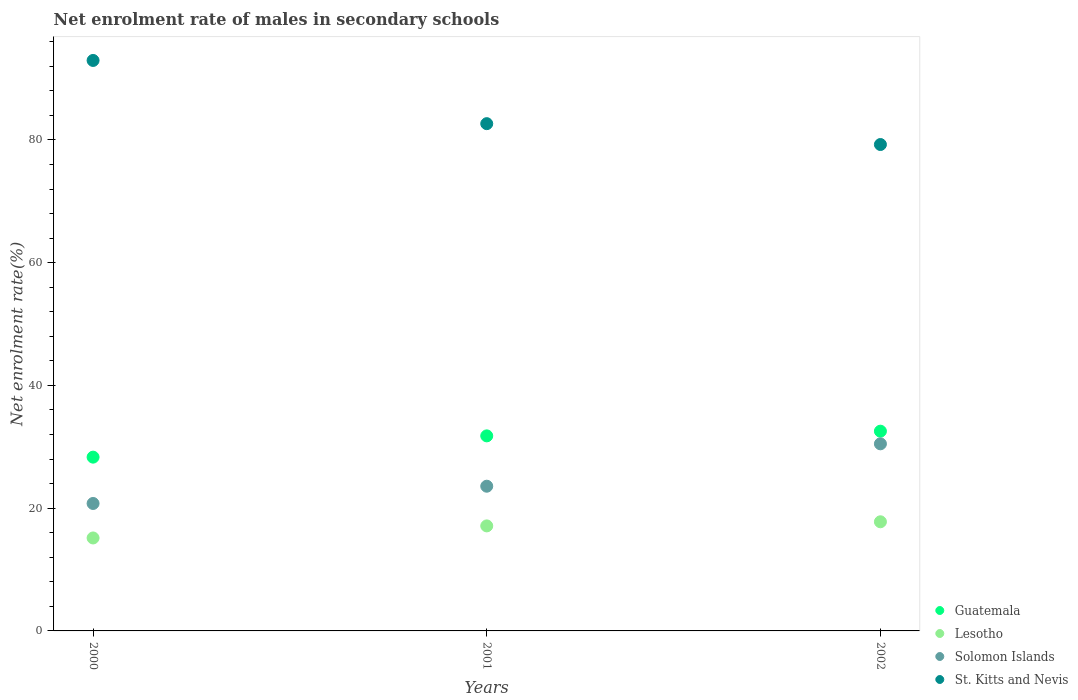How many different coloured dotlines are there?
Give a very brief answer. 4. What is the net enrolment rate of males in secondary schools in St. Kitts and Nevis in 2000?
Offer a very short reply. 92.95. Across all years, what is the maximum net enrolment rate of males in secondary schools in Guatemala?
Your answer should be very brief. 32.54. Across all years, what is the minimum net enrolment rate of males in secondary schools in Lesotho?
Offer a terse response. 15.15. What is the total net enrolment rate of males in secondary schools in Guatemala in the graph?
Your answer should be compact. 92.64. What is the difference between the net enrolment rate of males in secondary schools in Lesotho in 2000 and that in 2002?
Offer a terse response. -2.64. What is the difference between the net enrolment rate of males in secondary schools in Solomon Islands in 2001 and the net enrolment rate of males in secondary schools in Lesotho in 2000?
Offer a very short reply. 8.43. What is the average net enrolment rate of males in secondary schools in Guatemala per year?
Make the answer very short. 30.88. In the year 2002, what is the difference between the net enrolment rate of males in secondary schools in Solomon Islands and net enrolment rate of males in secondary schools in Guatemala?
Keep it short and to the point. -2.06. In how many years, is the net enrolment rate of males in secondary schools in Solomon Islands greater than 84 %?
Provide a short and direct response. 0. What is the ratio of the net enrolment rate of males in secondary schools in St. Kitts and Nevis in 2000 to that in 2002?
Keep it short and to the point. 1.17. Is the net enrolment rate of males in secondary schools in Solomon Islands in 2001 less than that in 2002?
Your response must be concise. Yes. What is the difference between the highest and the second highest net enrolment rate of males in secondary schools in Guatemala?
Your response must be concise. 0.76. What is the difference between the highest and the lowest net enrolment rate of males in secondary schools in St. Kitts and Nevis?
Provide a succinct answer. 13.7. Is it the case that in every year, the sum of the net enrolment rate of males in secondary schools in St. Kitts and Nevis and net enrolment rate of males in secondary schools in Lesotho  is greater than the net enrolment rate of males in secondary schools in Guatemala?
Offer a very short reply. Yes. Does the net enrolment rate of males in secondary schools in Lesotho monotonically increase over the years?
Your response must be concise. Yes. Is the net enrolment rate of males in secondary schools in Guatemala strictly less than the net enrolment rate of males in secondary schools in Lesotho over the years?
Your response must be concise. No. How many dotlines are there?
Your answer should be compact. 4. Are the values on the major ticks of Y-axis written in scientific E-notation?
Ensure brevity in your answer.  No. Does the graph contain any zero values?
Offer a terse response. No. Does the graph contain grids?
Provide a short and direct response. No. Where does the legend appear in the graph?
Provide a succinct answer. Bottom right. What is the title of the graph?
Keep it short and to the point. Net enrolment rate of males in secondary schools. What is the label or title of the Y-axis?
Offer a terse response. Net enrolment rate(%). What is the Net enrolment rate(%) of Guatemala in 2000?
Your answer should be very brief. 28.31. What is the Net enrolment rate(%) in Lesotho in 2000?
Keep it short and to the point. 15.15. What is the Net enrolment rate(%) of Solomon Islands in 2000?
Your response must be concise. 20.77. What is the Net enrolment rate(%) in St. Kitts and Nevis in 2000?
Provide a succinct answer. 92.95. What is the Net enrolment rate(%) of Guatemala in 2001?
Offer a very short reply. 31.78. What is the Net enrolment rate(%) in Lesotho in 2001?
Offer a very short reply. 17.11. What is the Net enrolment rate(%) of Solomon Islands in 2001?
Keep it short and to the point. 23.58. What is the Net enrolment rate(%) of St. Kitts and Nevis in 2001?
Make the answer very short. 82.65. What is the Net enrolment rate(%) of Guatemala in 2002?
Provide a succinct answer. 32.54. What is the Net enrolment rate(%) of Lesotho in 2002?
Your answer should be very brief. 17.78. What is the Net enrolment rate(%) of Solomon Islands in 2002?
Your answer should be compact. 30.48. What is the Net enrolment rate(%) in St. Kitts and Nevis in 2002?
Offer a terse response. 79.25. Across all years, what is the maximum Net enrolment rate(%) in Guatemala?
Provide a short and direct response. 32.54. Across all years, what is the maximum Net enrolment rate(%) in Lesotho?
Offer a terse response. 17.78. Across all years, what is the maximum Net enrolment rate(%) in Solomon Islands?
Offer a very short reply. 30.48. Across all years, what is the maximum Net enrolment rate(%) of St. Kitts and Nevis?
Your answer should be compact. 92.95. Across all years, what is the minimum Net enrolment rate(%) in Guatemala?
Ensure brevity in your answer.  28.31. Across all years, what is the minimum Net enrolment rate(%) in Lesotho?
Provide a succinct answer. 15.15. Across all years, what is the minimum Net enrolment rate(%) in Solomon Islands?
Give a very brief answer. 20.77. Across all years, what is the minimum Net enrolment rate(%) in St. Kitts and Nevis?
Keep it short and to the point. 79.25. What is the total Net enrolment rate(%) of Guatemala in the graph?
Provide a short and direct response. 92.64. What is the total Net enrolment rate(%) of Lesotho in the graph?
Make the answer very short. 50.04. What is the total Net enrolment rate(%) of Solomon Islands in the graph?
Make the answer very short. 74.83. What is the total Net enrolment rate(%) of St. Kitts and Nevis in the graph?
Your answer should be compact. 254.85. What is the difference between the Net enrolment rate(%) of Guatemala in 2000 and that in 2001?
Give a very brief answer. -3.47. What is the difference between the Net enrolment rate(%) in Lesotho in 2000 and that in 2001?
Provide a short and direct response. -1.97. What is the difference between the Net enrolment rate(%) of Solomon Islands in 2000 and that in 2001?
Offer a terse response. -2.81. What is the difference between the Net enrolment rate(%) of St. Kitts and Nevis in 2000 and that in 2001?
Offer a terse response. 10.3. What is the difference between the Net enrolment rate(%) of Guatemala in 2000 and that in 2002?
Provide a short and direct response. -4.23. What is the difference between the Net enrolment rate(%) of Lesotho in 2000 and that in 2002?
Give a very brief answer. -2.64. What is the difference between the Net enrolment rate(%) in Solomon Islands in 2000 and that in 2002?
Your answer should be compact. -9.72. What is the difference between the Net enrolment rate(%) in St. Kitts and Nevis in 2000 and that in 2002?
Provide a short and direct response. 13.7. What is the difference between the Net enrolment rate(%) of Guatemala in 2001 and that in 2002?
Your answer should be very brief. -0.76. What is the difference between the Net enrolment rate(%) in Lesotho in 2001 and that in 2002?
Provide a succinct answer. -0.67. What is the difference between the Net enrolment rate(%) of Solomon Islands in 2001 and that in 2002?
Provide a succinct answer. -6.91. What is the difference between the Net enrolment rate(%) in St. Kitts and Nevis in 2001 and that in 2002?
Provide a succinct answer. 3.4. What is the difference between the Net enrolment rate(%) of Guatemala in 2000 and the Net enrolment rate(%) of Lesotho in 2001?
Make the answer very short. 11.2. What is the difference between the Net enrolment rate(%) of Guatemala in 2000 and the Net enrolment rate(%) of Solomon Islands in 2001?
Make the answer very short. 4.74. What is the difference between the Net enrolment rate(%) in Guatemala in 2000 and the Net enrolment rate(%) in St. Kitts and Nevis in 2001?
Make the answer very short. -54.33. What is the difference between the Net enrolment rate(%) in Lesotho in 2000 and the Net enrolment rate(%) in Solomon Islands in 2001?
Keep it short and to the point. -8.43. What is the difference between the Net enrolment rate(%) in Lesotho in 2000 and the Net enrolment rate(%) in St. Kitts and Nevis in 2001?
Provide a succinct answer. -67.5. What is the difference between the Net enrolment rate(%) of Solomon Islands in 2000 and the Net enrolment rate(%) of St. Kitts and Nevis in 2001?
Keep it short and to the point. -61.88. What is the difference between the Net enrolment rate(%) in Guatemala in 2000 and the Net enrolment rate(%) in Lesotho in 2002?
Your response must be concise. 10.53. What is the difference between the Net enrolment rate(%) in Guatemala in 2000 and the Net enrolment rate(%) in Solomon Islands in 2002?
Offer a very short reply. -2.17. What is the difference between the Net enrolment rate(%) of Guatemala in 2000 and the Net enrolment rate(%) of St. Kitts and Nevis in 2002?
Your answer should be very brief. -50.94. What is the difference between the Net enrolment rate(%) of Lesotho in 2000 and the Net enrolment rate(%) of Solomon Islands in 2002?
Make the answer very short. -15.34. What is the difference between the Net enrolment rate(%) of Lesotho in 2000 and the Net enrolment rate(%) of St. Kitts and Nevis in 2002?
Provide a succinct answer. -64.1. What is the difference between the Net enrolment rate(%) of Solomon Islands in 2000 and the Net enrolment rate(%) of St. Kitts and Nevis in 2002?
Your response must be concise. -58.48. What is the difference between the Net enrolment rate(%) of Guatemala in 2001 and the Net enrolment rate(%) of Lesotho in 2002?
Your answer should be compact. 14. What is the difference between the Net enrolment rate(%) in Guatemala in 2001 and the Net enrolment rate(%) in Solomon Islands in 2002?
Make the answer very short. 1.3. What is the difference between the Net enrolment rate(%) of Guatemala in 2001 and the Net enrolment rate(%) of St. Kitts and Nevis in 2002?
Your answer should be compact. -47.47. What is the difference between the Net enrolment rate(%) in Lesotho in 2001 and the Net enrolment rate(%) in Solomon Islands in 2002?
Give a very brief answer. -13.37. What is the difference between the Net enrolment rate(%) in Lesotho in 2001 and the Net enrolment rate(%) in St. Kitts and Nevis in 2002?
Make the answer very short. -62.14. What is the difference between the Net enrolment rate(%) in Solomon Islands in 2001 and the Net enrolment rate(%) in St. Kitts and Nevis in 2002?
Offer a terse response. -55.67. What is the average Net enrolment rate(%) of Guatemala per year?
Your answer should be very brief. 30.88. What is the average Net enrolment rate(%) in Lesotho per year?
Your answer should be very brief. 16.68. What is the average Net enrolment rate(%) of Solomon Islands per year?
Offer a terse response. 24.94. What is the average Net enrolment rate(%) of St. Kitts and Nevis per year?
Keep it short and to the point. 84.95. In the year 2000, what is the difference between the Net enrolment rate(%) in Guatemala and Net enrolment rate(%) in Lesotho?
Offer a very short reply. 13.17. In the year 2000, what is the difference between the Net enrolment rate(%) in Guatemala and Net enrolment rate(%) in Solomon Islands?
Offer a very short reply. 7.55. In the year 2000, what is the difference between the Net enrolment rate(%) of Guatemala and Net enrolment rate(%) of St. Kitts and Nevis?
Your response must be concise. -64.63. In the year 2000, what is the difference between the Net enrolment rate(%) of Lesotho and Net enrolment rate(%) of Solomon Islands?
Keep it short and to the point. -5.62. In the year 2000, what is the difference between the Net enrolment rate(%) of Lesotho and Net enrolment rate(%) of St. Kitts and Nevis?
Your answer should be very brief. -77.8. In the year 2000, what is the difference between the Net enrolment rate(%) in Solomon Islands and Net enrolment rate(%) in St. Kitts and Nevis?
Your response must be concise. -72.18. In the year 2001, what is the difference between the Net enrolment rate(%) in Guatemala and Net enrolment rate(%) in Lesotho?
Your response must be concise. 14.67. In the year 2001, what is the difference between the Net enrolment rate(%) in Guatemala and Net enrolment rate(%) in Solomon Islands?
Offer a very short reply. 8.2. In the year 2001, what is the difference between the Net enrolment rate(%) of Guatemala and Net enrolment rate(%) of St. Kitts and Nevis?
Offer a terse response. -50.87. In the year 2001, what is the difference between the Net enrolment rate(%) of Lesotho and Net enrolment rate(%) of Solomon Islands?
Your answer should be compact. -6.47. In the year 2001, what is the difference between the Net enrolment rate(%) of Lesotho and Net enrolment rate(%) of St. Kitts and Nevis?
Provide a short and direct response. -65.54. In the year 2001, what is the difference between the Net enrolment rate(%) in Solomon Islands and Net enrolment rate(%) in St. Kitts and Nevis?
Your answer should be very brief. -59.07. In the year 2002, what is the difference between the Net enrolment rate(%) of Guatemala and Net enrolment rate(%) of Lesotho?
Offer a terse response. 14.76. In the year 2002, what is the difference between the Net enrolment rate(%) in Guatemala and Net enrolment rate(%) in Solomon Islands?
Give a very brief answer. 2.06. In the year 2002, what is the difference between the Net enrolment rate(%) of Guatemala and Net enrolment rate(%) of St. Kitts and Nevis?
Keep it short and to the point. -46.71. In the year 2002, what is the difference between the Net enrolment rate(%) in Lesotho and Net enrolment rate(%) in Solomon Islands?
Your answer should be very brief. -12.7. In the year 2002, what is the difference between the Net enrolment rate(%) of Lesotho and Net enrolment rate(%) of St. Kitts and Nevis?
Offer a very short reply. -61.47. In the year 2002, what is the difference between the Net enrolment rate(%) of Solomon Islands and Net enrolment rate(%) of St. Kitts and Nevis?
Your response must be concise. -48.77. What is the ratio of the Net enrolment rate(%) in Guatemala in 2000 to that in 2001?
Your response must be concise. 0.89. What is the ratio of the Net enrolment rate(%) of Lesotho in 2000 to that in 2001?
Offer a terse response. 0.89. What is the ratio of the Net enrolment rate(%) of Solomon Islands in 2000 to that in 2001?
Make the answer very short. 0.88. What is the ratio of the Net enrolment rate(%) of St. Kitts and Nevis in 2000 to that in 2001?
Your answer should be very brief. 1.12. What is the ratio of the Net enrolment rate(%) of Guatemala in 2000 to that in 2002?
Offer a terse response. 0.87. What is the ratio of the Net enrolment rate(%) of Lesotho in 2000 to that in 2002?
Provide a short and direct response. 0.85. What is the ratio of the Net enrolment rate(%) of Solomon Islands in 2000 to that in 2002?
Offer a terse response. 0.68. What is the ratio of the Net enrolment rate(%) in St. Kitts and Nevis in 2000 to that in 2002?
Offer a very short reply. 1.17. What is the ratio of the Net enrolment rate(%) of Guatemala in 2001 to that in 2002?
Your response must be concise. 0.98. What is the ratio of the Net enrolment rate(%) in Lesotho in 2001 to that in 2002?
Make the answer very short. 0.96. What is the ratio of the Net enrolment rate(%) of Solomon Islands in 2001 to that in 2002?
Provide a short and direct response. 0.77. What is the ratio of the Net enrolment rate(%) of St. Kitts and Nevis in 2001 to that in 2002?
Provide a short and direct response. 1.04. What is the difference between the highest and the second highest Net enrolment rate(%) of Guatemala?
Your response must be concise. 0.76. What is the difference between the highest and the second highest Net enrolment rate(%) of Lesotho?
Provide a short and direct response. 0.67. What is the difference between the highest and the second highest Net enrolment rate(%) in Solomon Islands?
Your response must be concise. 6.91. What is the difference between the highest and the second highest Net enrolment rate(%) of St. Kitts and Nevis?
Offer a very short reply. 10.3. What is the difference between the highest and the lowest Net enrolment rate(%) in Guatemala?
Your answer should be very brief. 4.23. What is the difference between the highest and the lowest Net enrolment rate(%) of Lesotho?
Provide a short and direct response. 2.64. What is the difference between the highest and the lowest Net enrolment rate(%) in Solomon Islands?
Your response must be concise. 9.72. What is the difference between the highest and the lowest Net enrolment rate(%) of St. Kitts and Nevis?
Offer a very short reply. 13.7. 